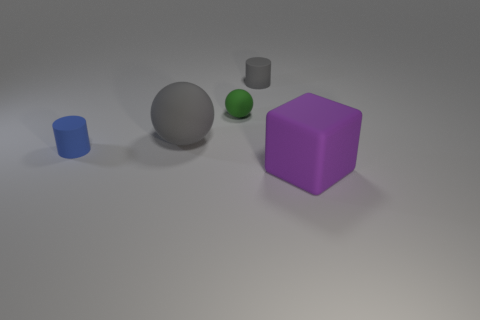Add 2 small gray objects. How many objects exist? 7 Subtract all cylinders. How many objects are left? 3 Add 3 big purple objects. How many big purple objects exist? 4 Subtract 0 cyan spheres. How many objects are left? 5 Subtract all large purple things. Subtract all large balls. How many objects are left? 3 Add 2 big purple rubber blocks. How many big purple rubber blocks are left? 3 